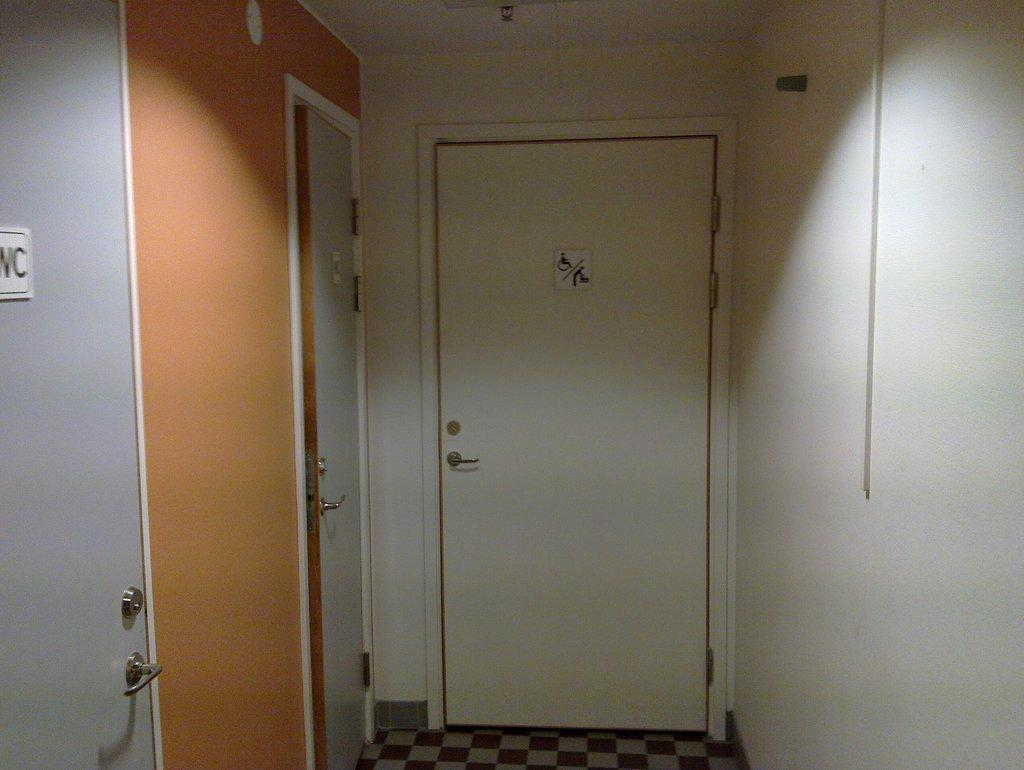What is the main architectural feature in the image? There is a door in the image. What is located on the right side of the image? There is a wall on the right side of the image. How many doors are visible on the left side of the image? There are two doors on the left side of the image. What type of sweater is the rabbit wearing in the image? There is no rabbit or sweater present in the image. How many bears can be seen playing with the doors in the image? There are no bears present in the image, and therefore no such activity can be observed. 